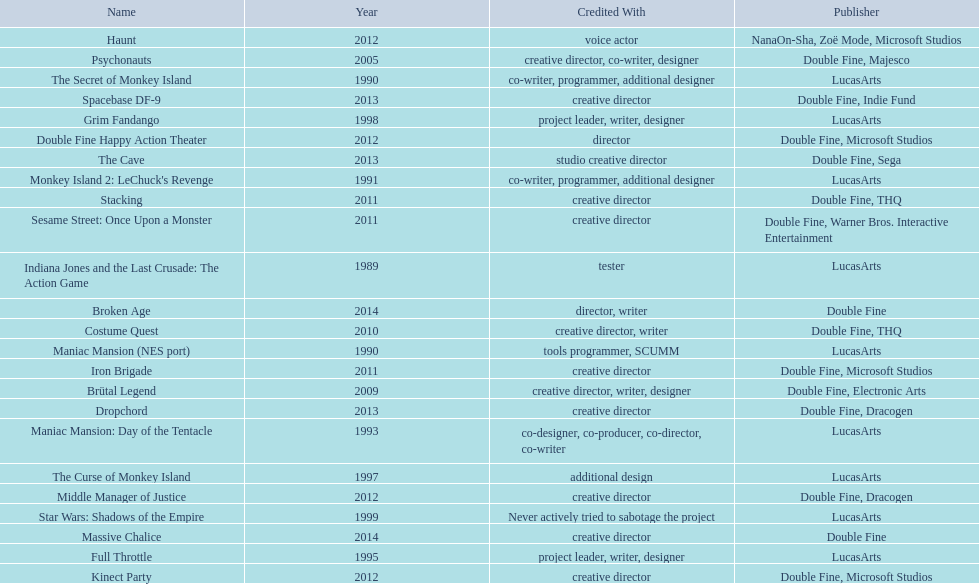What game name has tim schafer been involved with? Indiana Jones and the Last Crusade: The Action Game, Maniac Mansion (NES port), The Secret of Monkey Island, Monkey Island 2: LeChuck's Revenge, Maniac Mansion: Day of the Tentacle, Full Throttle, The Curse of Monkey Island, Grim Fandango, Star Wars: Shadows of the Empire, Psychonauts, Brütal Legend, Costume Quest, Stacking, Iron Brigade, Sesame Street: Once Upon a Monster, Haunt, Double Fine Happy Action Theater, Middle Manager of Justice, Kinect Party, The Cave, Dropchord, Spacebase DF-9, Broken Age, Massive Chalice. Which game has credit with just creative director? Creative director, creative director, creative director, creative director, creative director, creative director, creative director, creative director. Which games have the above and warner bros. interactive entertainment as publisher? Sesame Street: Once Upon a Monster. 